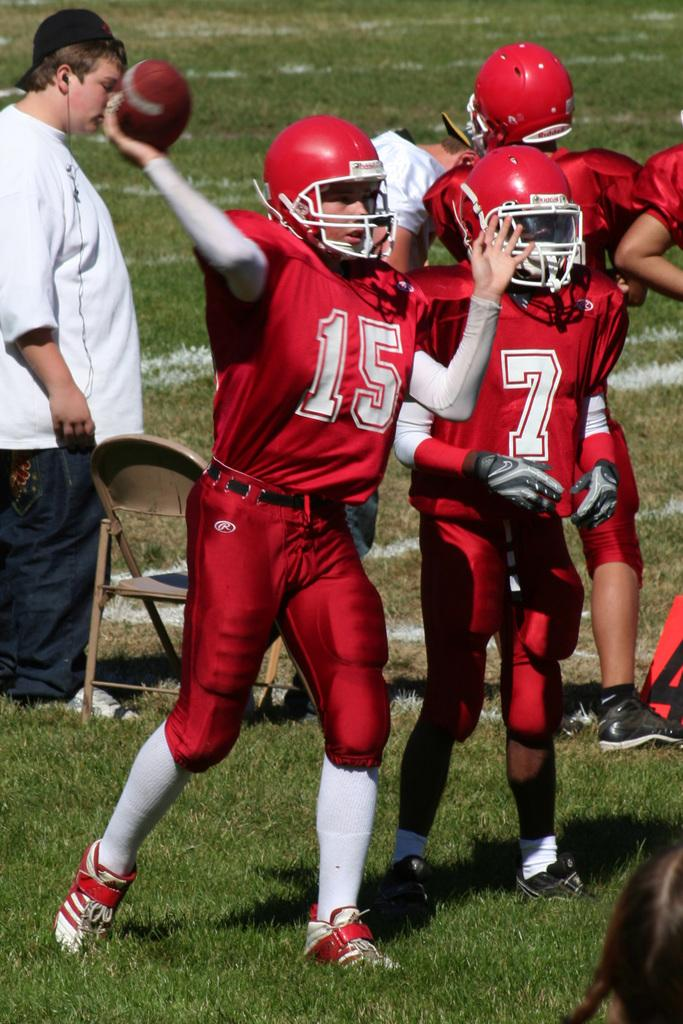What is happening in the image involving a group of people? The people in the image are playing with a ball. What are the people wearing in the image? The people are wearing red dresses. Can you describe the man in the image? There is a man standing in the image, and he is beside a chair. What type of punishment is being administered to the people wearing red dresses in the image? There is no punishment being administered in the image; the people are playing with a ball. What kind of loaf is being served to the people in the image? There is no loaf present in the image; the people are wearing red dresses and playing with a ball. 